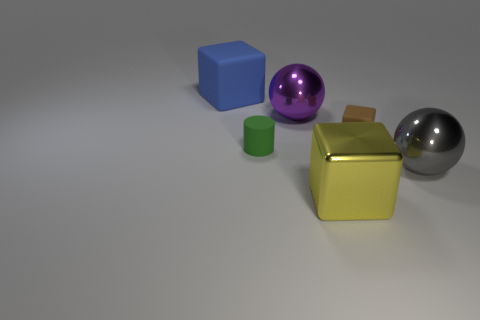Subtract all big blocks. How many blocks are left? 1 Add 3 gray things. How many objects exist? 9 Subtract all cylinders. How many objects are left? 5 Add 6 blue things. How many blue things exist? 7 Subtract 1 green cylinders. How many objects are left? 5 Subtract all metallic things. Subtract all big yellow blocks. How many objects are left? 2 Add 1 large matte things. How many large matte things are left? 2 